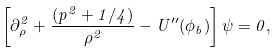<formula> <loc_0><loc_0><loc_500><loc_500>\left [ \partial _ { \rho } ^ { 2 } + \frac { ( p ^ { 2 } + 1 / 4 ) } { \rho ^ { 2 } } - U ^ { \prime \prime } ( \phi _ { b } ) \right ] \psi = 0 ,</formula> 